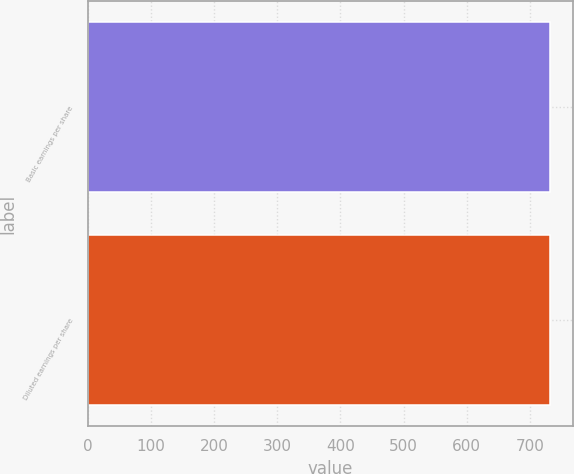<chart> <loc_0><loc_0><loc_500><loc_500><bar_chart><fcel>Basic earnings per share<fcel>Diluted earnings per share<nl><fcel>732.1<fcel>732.2<nl></chart> 